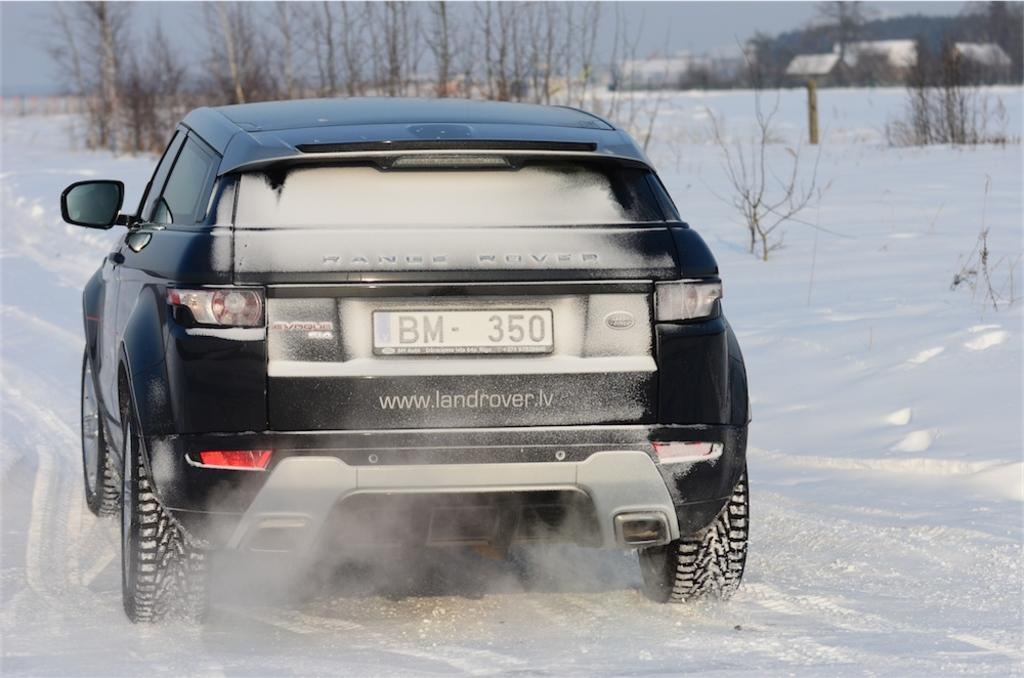Provide a one-sentence caption for the provided image. Black Land Rover with the plate BM350 on the book. 